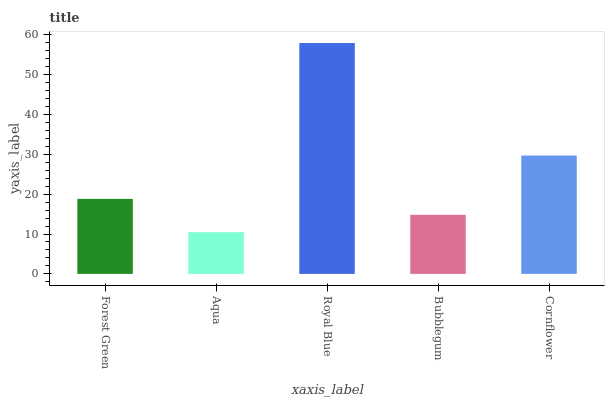Is Aqua the minimum?
Answer yes or no. Yes. Is Royal Blue the maximum?
Answer yes or no. Yes. Is Royal Blue the minimum?
Answer yes or no. No. Is Aqua the maximum?
Answer yes or no. No. Is Royal Blue greater than Aqua?
Answer yes or no. Yes. Is Aqua less than Royal Blue?
Answer yes or no. Yes. Is Aqua greater than Royal Blue?
Answer yes or no. No. Is Royal Blue less than Aqua?
Answer yes or no. No. Is Forest Green the high median?
Answer yes or no. Yes. Is Forest Green the low median?
Answer yes or no. Yes. Is Royal Blue the high median?
Answer yes or no. No. Is Royal Blue the low median?
Answer yes or no. No. 